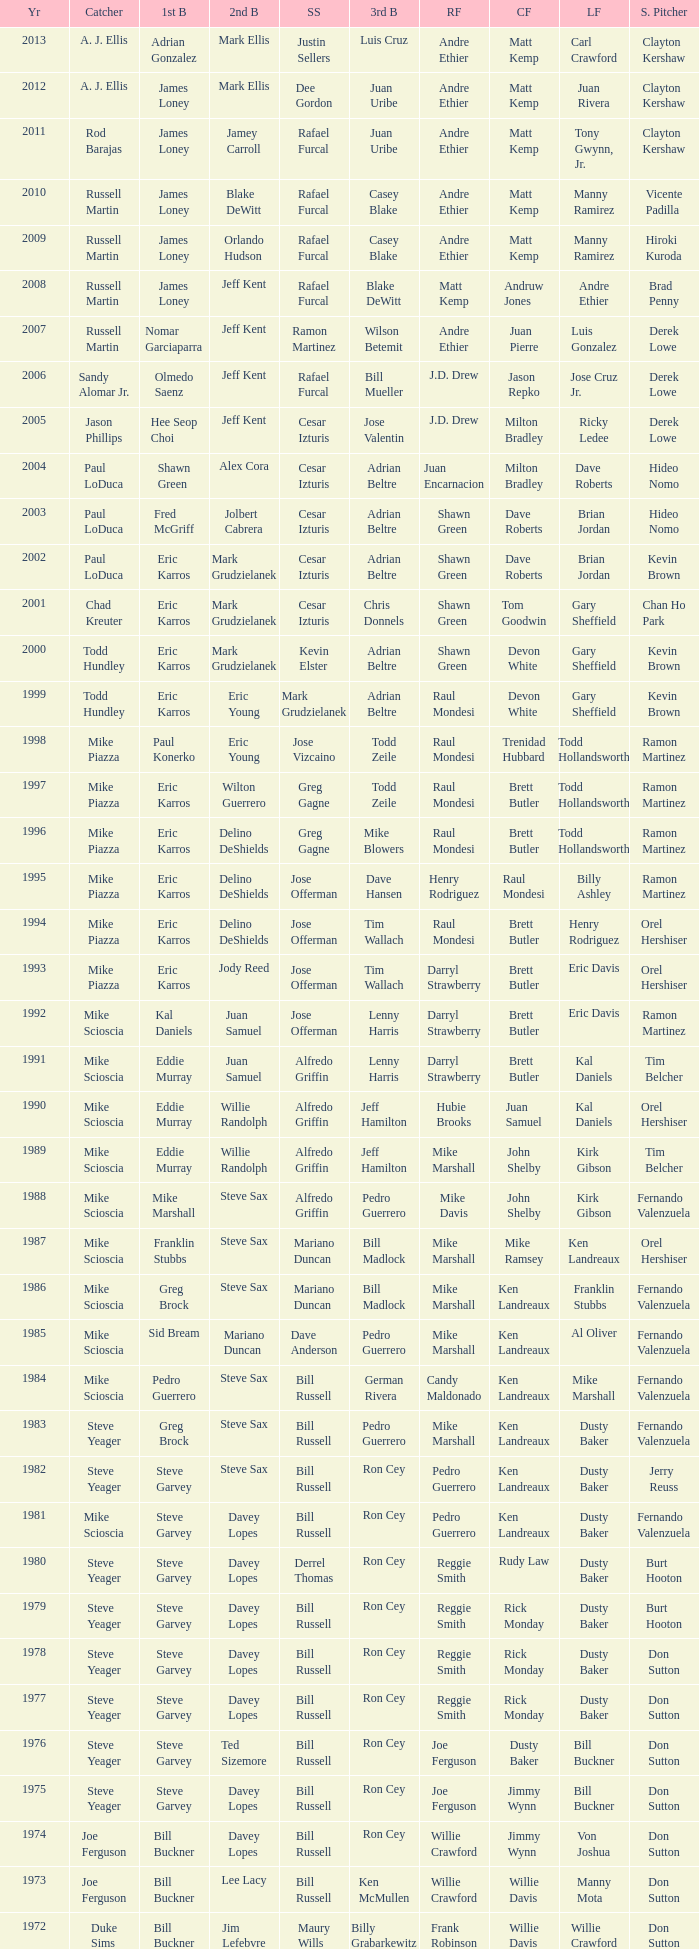Who was the SS when jim lefebvre was at 2nd, willie davis at CF, and don drysdale was the SP. Maury Wills. 